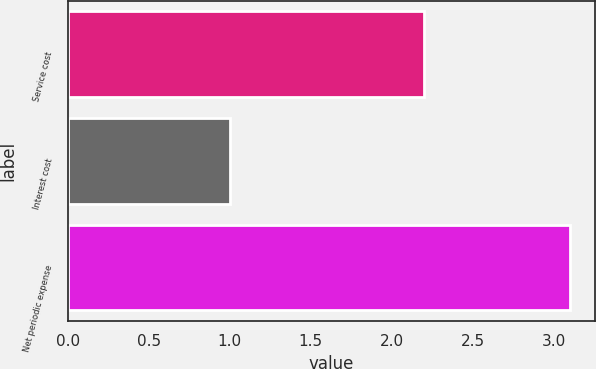<chart> <loc_0><loc_0><loc_500><loc_500><bar_chart><fcel>Service cost<fcel>Interest cost<fcel>Net periodic expense<nl><fcel>2.2<fcel>1<fcel>3.1<nl></chart> 